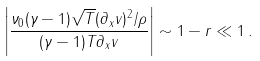<formula> <loc_0><loc_0><loc_500><loc_500>\left | \frac { \nu _ { 0 } ( \gamma - 1 ) \sqrt { T } ( \partial _ { x } v ) ^ { 2 } / \rho } { ( \gamma - 1 ) T \partial _ { x } v } \right | \sim 1 - r \ll 1 \, .</formula> 